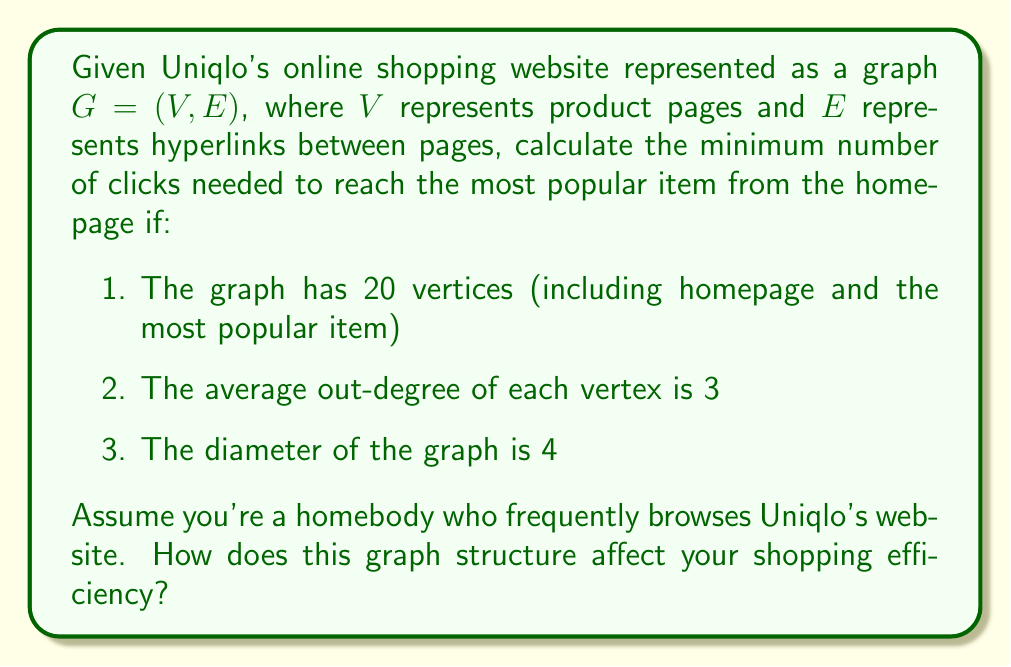Help me with this question. Let's approach this step-by-step:

1) First, we need to understand what the diameter of a graph represents. The diameter is the maximum shortest path between any two vertices in the graph.

2) Given that the diameter is 4, this means that the longest shortest path between any two vertices is 4 edges.

3) Since we're looking for the minimum number of clicks (edges) to reach the most popular item from the homepage, this path cannot be longer than the diameter.

4) However, the actual shortest path could be less than or equal to the diameter.

5) In the worst-case scenario, the path from the homepage to the most popular item would be equal to the diameter.

6) Therefore, the minimum number of clicks needed to reach the most popular item from the homepage is at most 4.

7) For a homebody who frequently browses Uniqlo's website, this graph structure is quite efficient. With an average out-degree of 3, each page provides multiple options to navigate, and with a diameter of only 4, any product can be reached in at most 4 clicks.

8) The efficiency can be quantified using the following formula:

   $$E = \frac{|V|}{d}$$

   Where $E$ is efficiency, $|V|$ is the number of vertices, and $d$ is the diameter.

9) In this case:

   $$E = \frac{20}{4} = 5$$

   This means that on average, each click brings you 5 steps closer to any product in the worst-case scenario, which is quite efficient for online shopping.
Answer: 4 clicks 